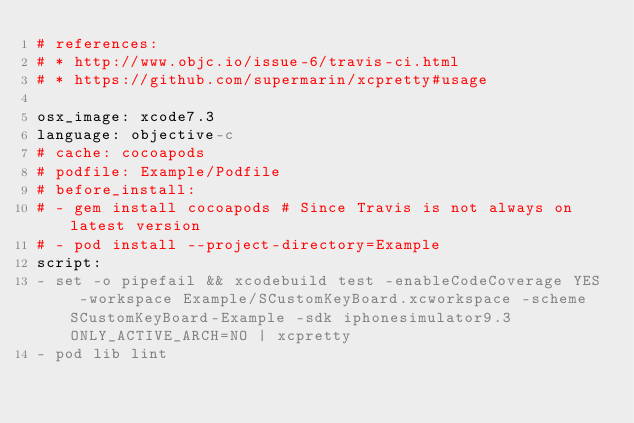Convert code to text. <code><loc_0><loc_0><loc_500><loc_500><_YAML_># references:
# * http://www.objc.io/issue-6/travis-ci.html
# * https://github.com/supermarin/xcpretty#usage

osx_image: xcode7.3
language: objective-c
# cache: cocoapods
# podfile: Example/Podfile
# before_install:
# - gem install cocoapods # Since Travis is not always on latest version
# - pod install --project-directory=Example
script:
- set -o pipefail && xcodebuild test -enableCodeCoverage YES -workspace Example/SCustomKeyBoard.xcworkspace -scheme SCustomKeyBoard-Example -sdk iphonesimulator9.3 ONLY_ACTIVE_ARCH=NO | xcpretty
- pod lib lint
</code> 